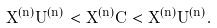<formula> <loc_0><loc_0><loc_500><loc_500>X ^ { ( n ) } U ^ { ( n ) } < X ^ { ( n ) } C < X ^ { ( n ) } \bar { U } ^ { ( n ) } .</formula> 